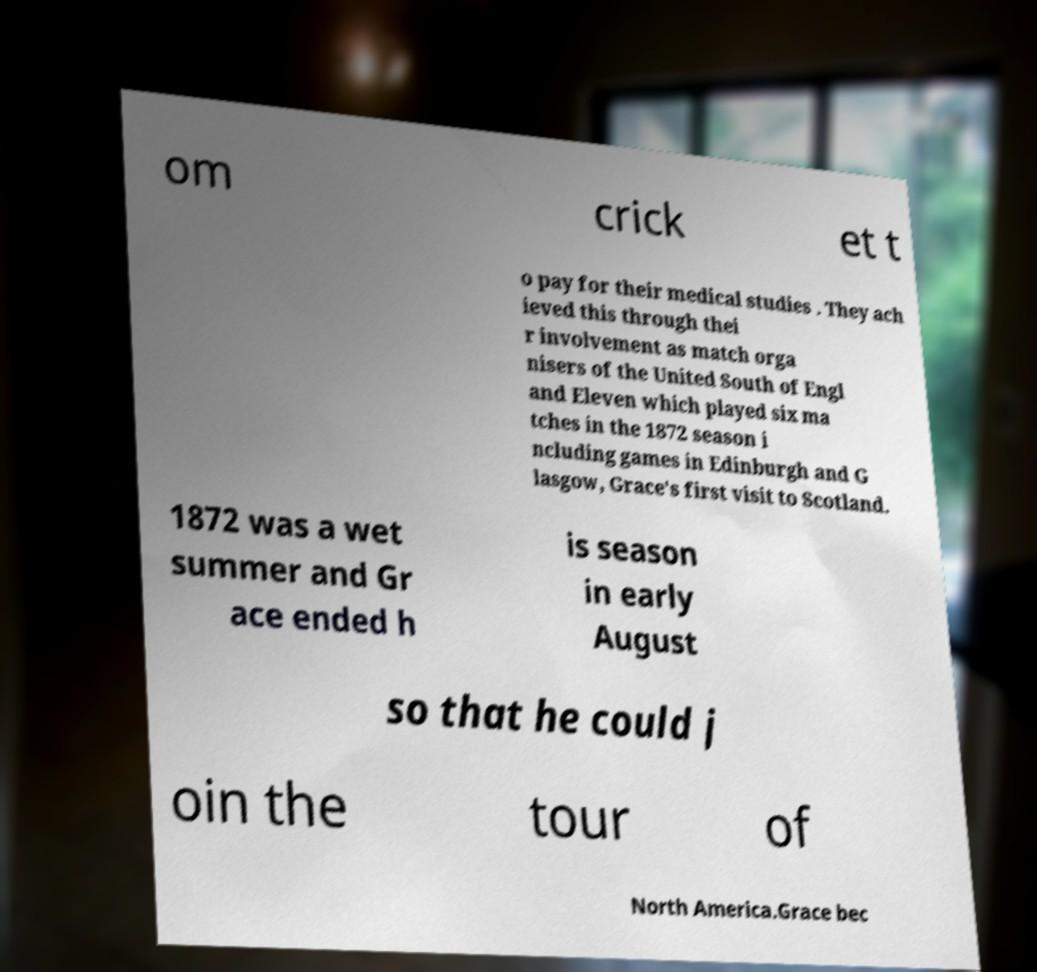Please identify and transcribe the text found in this image. om crick et t o pay for their medical studies . They ach ieved this through thei r involvement as match orga nisers of the United South of Engl and Eleven which played six ma tches in the 1872 season i ncluding games in Edinburgh and G lasgow, Grace's first visit to Scotland. 1872 was a wet summer and Gr ace ended h is season in early August so that he could j oin the tour of North America.Grace bec 